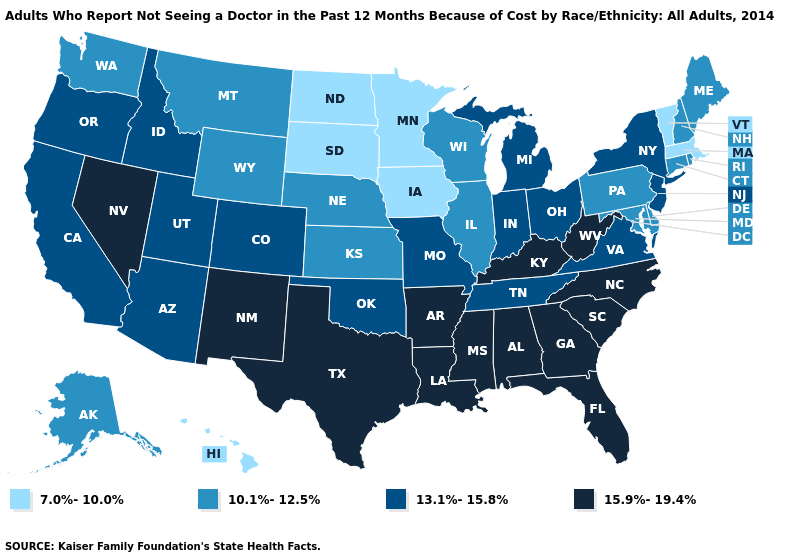What is the lowest value in the MidWest?
Quick response, please. 7.0%-10.0%. Is the legend a continuous bar?
Write a very short answer. No. Does North Dakota have the same value as Minnesota?
Concise answer only. Yes. Name the states that have a value in the range 13.1%-15.8%?
Quick response, please. Arizona, California, Colorado, Idaho, Indiana, Michigan, Missouri, New Jersey, New York, Ohio, Oklahoma, Oregon, Tennessee, Utah, Virginia. What is the value of Indiana?
Be succinct. 13.1%-15.8%. Name the states that have a value in the range 15.9%-19.4%?
Give a very brief answer. Alabama, Arkansas, Florida, Georgia, Kentucky, Louisiana, Mississippi, Nevada, New Mexico, North Carolina, South Carolina, Texas, West Virginia. What is the value of Wyoming?
Answer briefly. 10.1%-12.5%. Which states have the highest value in the USA?
Be succinct. Alabama, Arkansas, Florida, Georgia, Kentucky, Louisiana, Mississippi, Nevada, New Mexico, North Carolina, South Carolina, Texas, West Virginia. What is the highest value in states that border New Mexico?
Concise answer only. 15.9%-19.4%. What is the value of Michigan?
Short answer required. 13.1%-15.8%. What is the value of Maine?
Concise answer only. 10.1%-12.5%. What is the value of Arizona?
Give a very brief answer. 13.1%-15.8%. Name the states that have a value in the range 7.0%-10.0%?
Quick response, please. Hawaii, Iowa, Massachusetts, Minnesota, North Dakota, South Dakota, Vermont. What is the highest value in states that border Nevada?
Keep it brief. 13.1%-15.8%. Does Utah have the highest value in the West?
Concise answer only. No. 